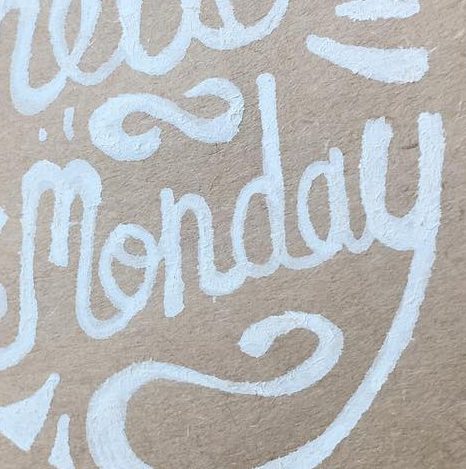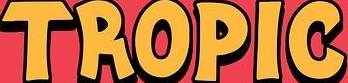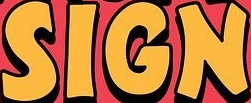Read the text content from these images in order, separated by a semicolon. monday; TROPIC; SIGN 